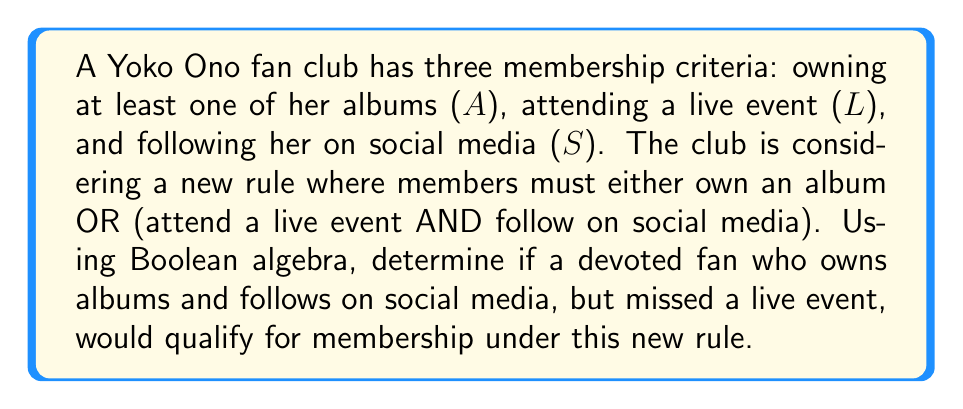Show me your answer to this math problem. Let's approach this step-by-step using Boolean algebra:

1) First, let's express the new membership rule as a Boolean expression:
   $$ A + (L \cdot S) $$
   Where '+' represents OR, and '·' represents AND.

2) Now, let's consider the fan's status:
   - Owns albums (A): True
   - Attended live event (L): False
   - Follows on social media (S): True

3) We can represent this as:
   $$ A = 1, L = 0, S = 1 $$

4) Let's substitute these values into our expression:
   $$ 1 + (0 \cdot 1) $$

5) Evaluate the AND operation first:
   $$ 1 + (0) $$

6) Now, evaluate the OR operation:
   $$ 1 + 0 = 1 $$

7) In Boolean algebra, 1 represents True.

Therefore, the fan would qualify for membership under the new rule.
Answer: True 